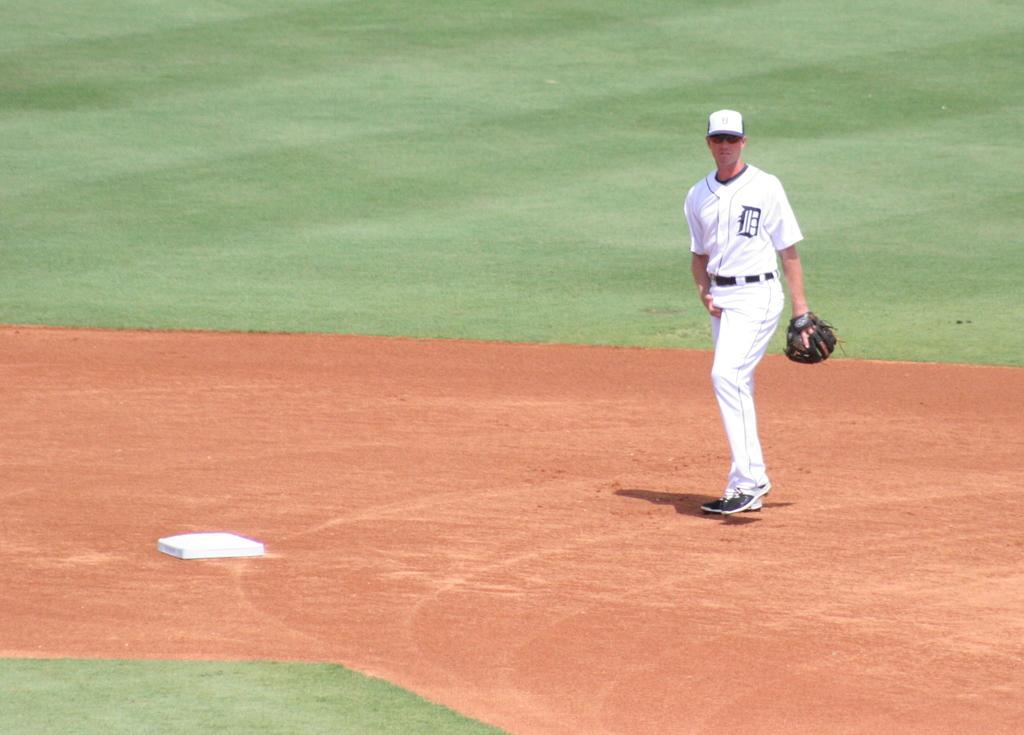Who is the main subject in the foreground of the image? There is a man in the foreground of the image. What is the man wearing? The man is wearing a white dress. What is the man doing in the image? The man is walking on the ground. What type of vegetation can be seen in the background and bottom of the image? There is grass in the background and bottom of the image. What is the man teaching in the image? There is no indication in the image that the man is teaching anything. Can you see a basket in the man's hand in the image? There is no basket visible in the man's hand or anywhere else in the image. 